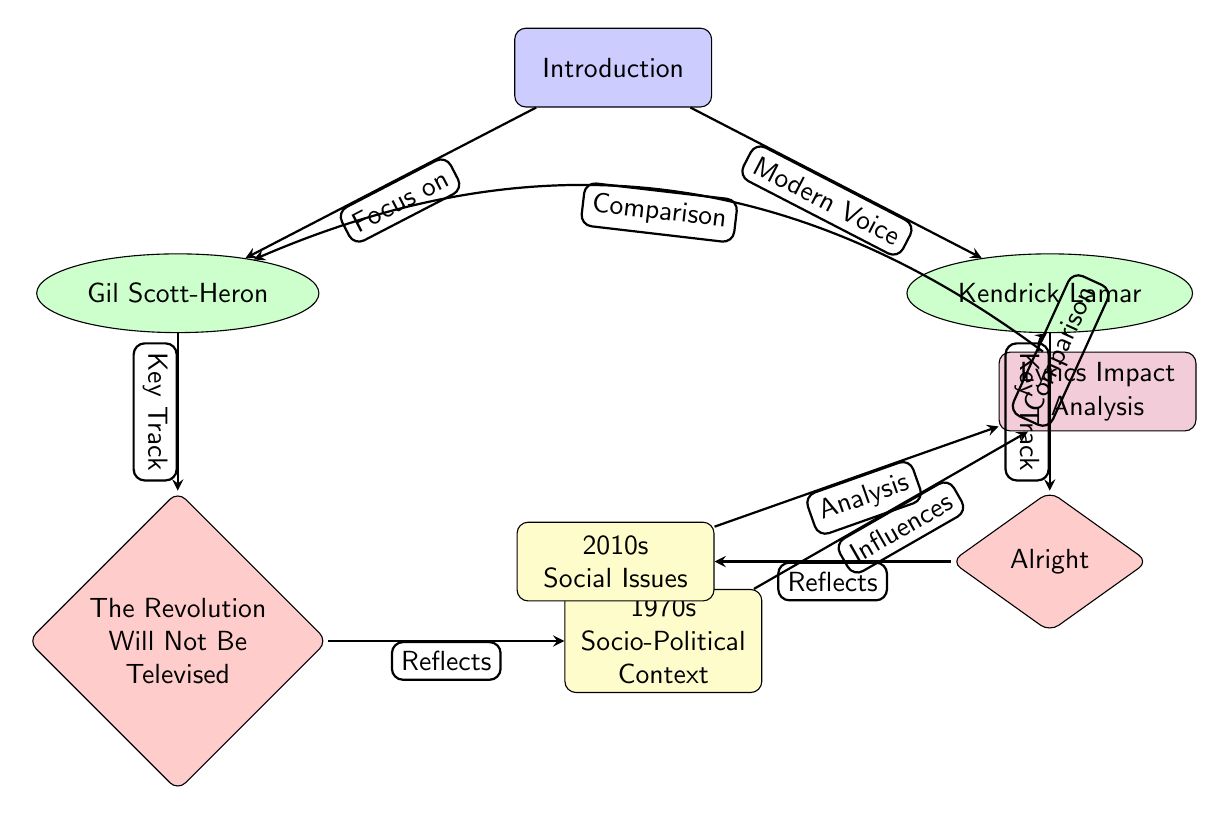What's the title of the key track associated with Gil Scott-Heron? The diagram shows that the key track associated with Gil Scott-Heron is “The Revolution Will Not Be Televised,” as indicated in the diamond node below the artist node.
Answer: The Revolution Will Not Be Televised How many artists are depicted in the diagram? By counting the nodes labeled as artists, we see two artists: Gil Scott-Heron and Kendrick Lamar. Therefore, the total number of artists is two.
Answer: 2 Which song reflects the social issues of the 2010s? The node for the song "Alright" associated with Kendrick Lamar indicates that it reflects the social issues of the 2010s, as shown in the context node on the left.
Answer: Alright What is the relationship between the song “The Revolution Will Not Be Televised” and the 1970s socio-political context? The arrow labeled "Reflects" clearly indicates that “The Revolution Will Not Be Televised” reflects the socio-political context of the 1970s, connecting the song to the relevant historical backdrop.
Answer: Reflects What are the two main focuses of the analysis in the diagram? The diagram shows that the analysis focuses on both Gil Scott-Heron and Kendrick Lamar, as indicated by the connections drawn to both artists in the top node labeled "Lyrics Impact Analysis."
Answer: Gil Scott-Heron, Kendrick Lamar How are the two artists compared in the analysis? The connections labeled "Comparison" on either side show that both artists are included in the analysis; thus, they are compared based on their socio-political lyrics across different eras.
Answer: Comparison What does the node “Lyrics Impact Analysis” summarize? The node “Lyrics Impact Analysis” summarizes the influence of the socio-political lyrics from the two highlighted songs and their historical contexts, connecting these influences to the modern socio-cultural landscape.
Answer: Influence of socio-political lyrics What does the arrow from "2010s Social Issues" to “Lyrics Impact Analysis” signify? This arrow indicates that the social issues prevalent in the 2010s inform and influence the analysis of lyrics, emphasizing the connection between societal context and lyrical content.
Answer: Influence on analysis 